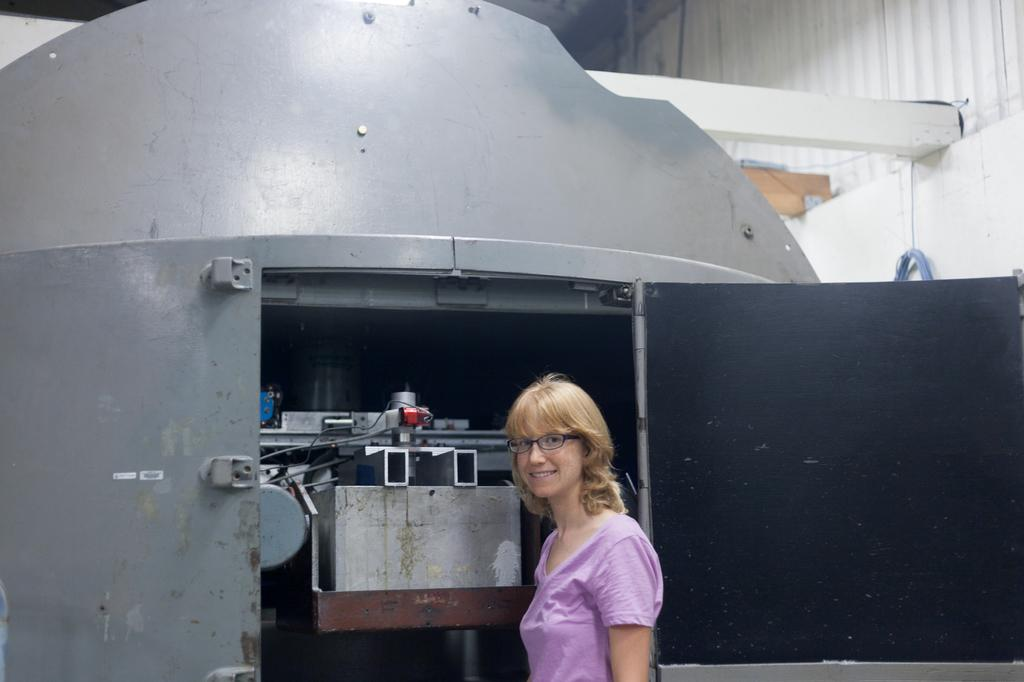What is the woman doing in the image? The woman is standing in front of a machine. What can be seen in the top right of the image? There is a pole and a fence in the top right of the image. How many quarters are visible in the image? There are no quarters present in the image. What type of store is located near the woman in the image? There is no store visible in the image. 